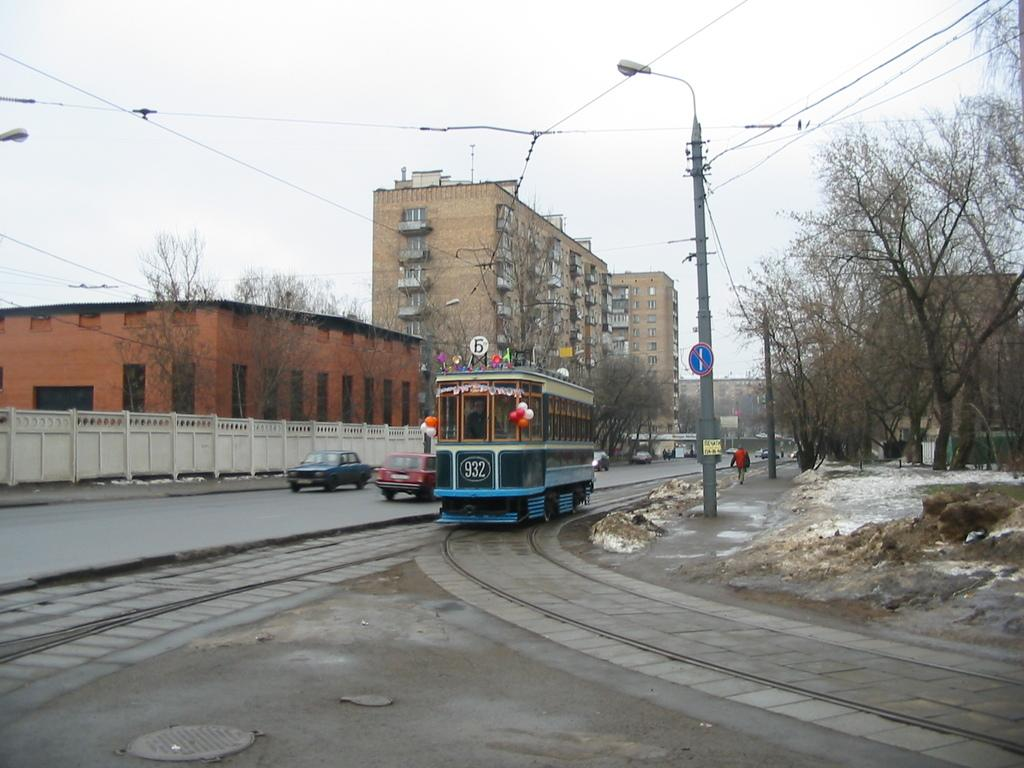<image>
Share a concise interpretation of the image provided. the trolley 932 is coming down the tracks on a cold day 